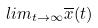<formula> <loc_0><loc_0><loc_500><loc_500>l i m _ { t \rightarrow \infty } \overline { x } ( t )</formula> 